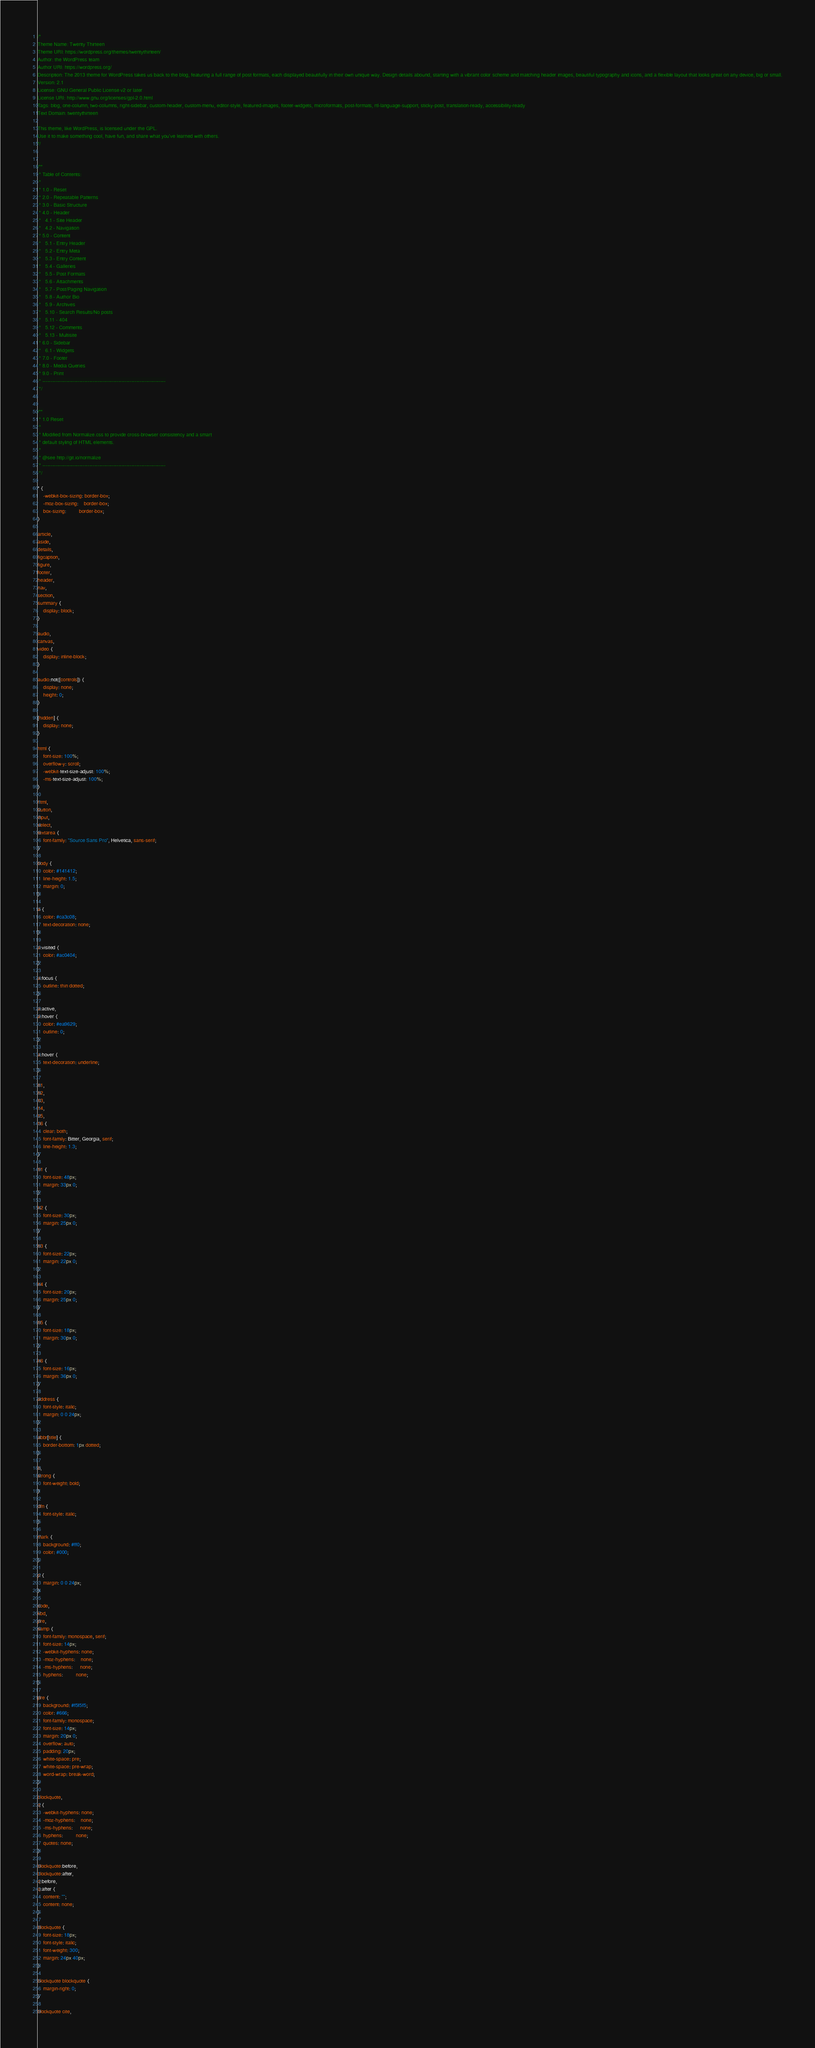<code> <loc_0><loc_0><loc_500><loc_500><_CSS_>/*
Theme Name: Twenty Thirteen
Theme URI: https://wordpress.org/themes/twentythirteen/
Author: the WordPress team
Author URI: https://wordpress.org/
Description: The 2013 theme for WordPress takes us back to the blog, featuring a full range of post formats, each displayed beautifully in their own unique way. Design details abound, starting with a vibrant color scheme and matching header images, beautiful typography and icons, and a flexible layout that looks great on any device, big or small.
Version: 2.1
License: GNU General Public License v2 or later
License URI: http://www.gnu.org/licenses/gpl-2.0.html
Tags: blog, one-column, two-columns, right-sidebar, custom-header, custom-menu, editor-style, featured-images, footer-widgets, microformats, post-formats, rtl-language-support, sticky-post, translation-ready, accessibility-ready
Text Domain: twentythirteen

This theme, like WordPress, is licensed under the GPL.
Use it to make something cool, have fun, and share what you've learned with others.
*/


/**
 * Table of Contents:
 *
 * 1.0 - Reset
 * 2.0 - Repeatable Patterns
 * 3.0 - Basic Structure
 * 4.0 - Header
 *   4.1 - Site Header
 *   4.2 - Navigation
 * 5.0 - Content
 *   5.1 - Entry Header
 *   5.2 - Entry Meta
 *   5.3 - Entry Content
 *   5.4 - Galleries
 *   5.5 - Post Formats
 *   5.6 - Attachments
 *   5.7 - Post/Paging Navigation
 *   5.8 - Author Bio
 *   5.9 - Archives
 *   5.10 - Search Results/No posts
 *   5.11 - 404
 *   5.12 - Comments
 *   5.13 - Multisite
 * 6.0 - Sidebar
 *   6.1 - Widgets
 * 7.0 - Footer
 * 8.0 - Media Queries
 * 9.0 - Print
 * ----------------------------------------------------------------------------
 */


/**
 * 1.0 Reset
 *
 * Modified from Normalize.css to provide cross-browser consistency and a smart
 * default styling of HTML elements.
 *
 * @see http://git.io/normalize
 * ----------------------------------------------------------------------------
 */

* {
	-webkit-box-sizing: border-box;
	-moz-box-sizing:    border-box;
	box-sizing:         border-box;
}

article,
aside,
details,
figcaption,
figure,
footer,
header,
nav,
section,
summary {
	display: block;
}

audio,
canvas,
video {
	display: inline-block;
}

audio:not([controls]) {
	display: none;
	height: 0;
}

[hidden] {
	display: none;
}

html {
	font-size: 100%;
	overflow-y: scroll;
	-webkit-text-size-adjust: 100%;
	-ms-text-size-adjust: 100%;
}

html,
button,
input,
select,
textarea {
	font-family: "Source Sans Pro", Helvetica, sans-serif;
}

body {
	color: #141412;
	line-height: 1.5;
	margin: 0;
}

a {
	color: #ca3c08;
	text-decoration: none;
}

a:visited {
	color: #ac0404;
}

a:focus {
	outline: thin dotted;
}

a:active,
a:hover {
	color: #ea9629;
	outline: 0;
}

a:hover {
	text-decoration: underline;
}

h1,
h2,
h3,
h4,
h5,
h6 {
	clear: both;
	font-family: Bitter, Georgia, serif;
	line-height: 1.3;
}

h1 {
	font-size: 48px;
	margin: 33px 0;
}

h2 {
	font-size: 30px;
	margin: 25px 0;
}

h3 {
	font-size: 22px;
	margin: 22px 0;
}

h4 {
	font-size: 20px;
	margin: 25px 0;
}

h5 {
	font-size: 18px;
	margin: 30px 0;
}

h6 {
	font-size: 16px;
	margin: 36px 0;
}

address {
	font-style: italic;
	margin: 0 0 24px;
}

abbr[title] {
	border-bottom: 1px dotted;
}

b,
strong {
	font-weight: bold;
}

dfn {
	font-style: italic;
}

mark {
	background: #ff0;
	color: #000;
}

p {
	margin: 0 0 24px;
}

code,
kbd,
pre,
samp {
	font-family: monospace, serif;
	font-size: 14px;
	-webkit-hyphens: none;
	-moz-hyphens:    none;
	-ms-hyphens:     none;
	hyphens:         none;
}

pre {
	background: #f5f5f5;
	color: #666;
	font-family: monospace;
	font-size: 14px;
	margin: 20px 0;
	overflow: auto;
	padding: 20px;
	white-space: pre;
	white-space: pre-wrap;
	word-wrap: break-word;
}

blockquote,
q {
	-webkit-hyphens: none;
	-moz-hyphens:    none;
	-ms-hyphens:     none;
	hyphens:         none;
	quotes: none;
}

blockquote:before,
blockquote:after,
q:before,
q:after {
	content: "";
	content: none;
}

blockquote {
	font-size: 18px;
	font-style: italic;
	font-weight: 300;
	margin: 24px 40px;
}

blockquote blockquote {
	margin-right: 0;
}

blockquote cite,</code> 